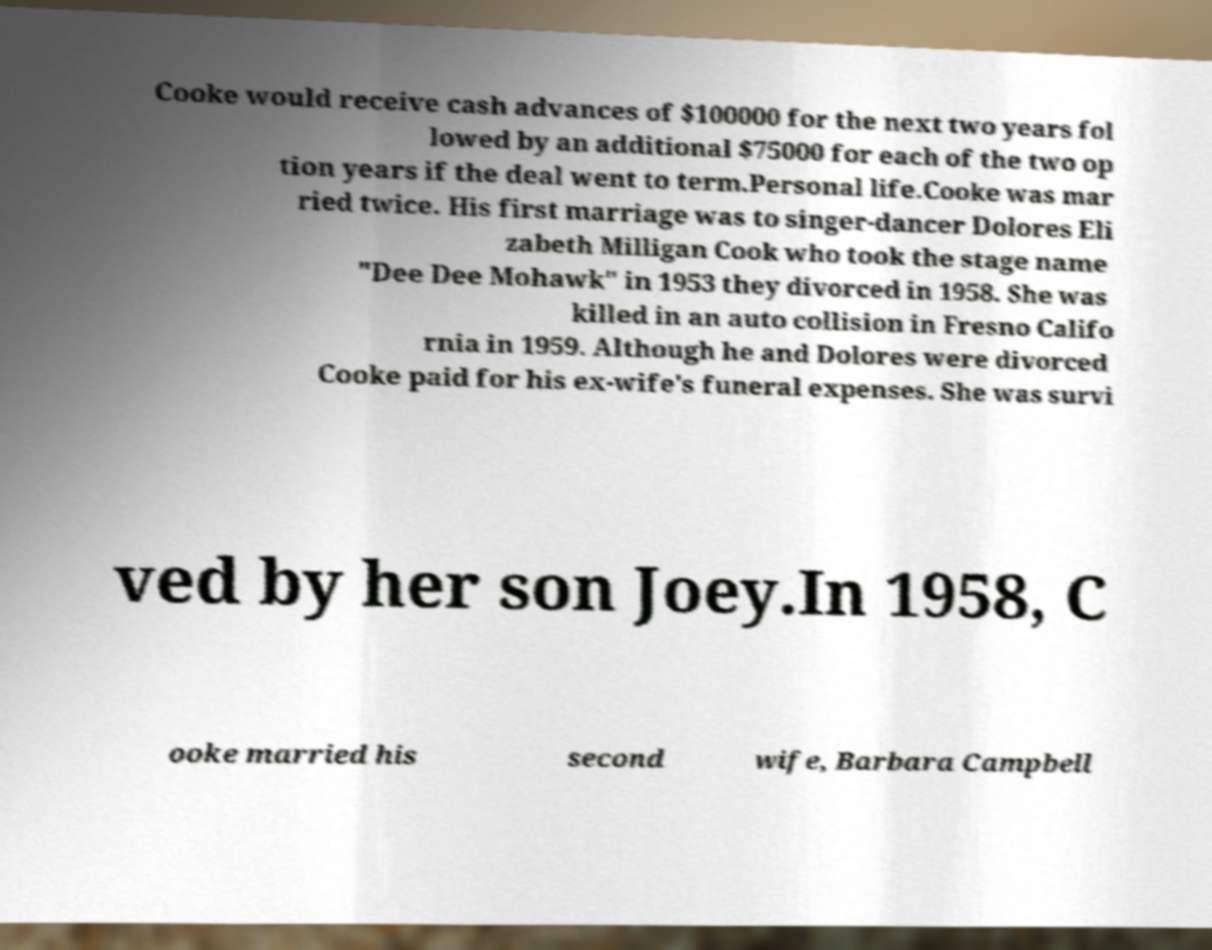I need the written content from this picture converted into text. Can you do that? Cooke would receive cash advances of $100000 for the next two years fol lowed by an additional $75000 for each of the two op tion years if the deal went to term.Personal life.Cooke was mar ried twice. His first marriage was to singer-dancer Dolores Eli zabeth Milligan Cook who took the stage name "Dee Dee Mohawk" in 1953 they divorced in 1958. She was killed in an auto collision in Fresno Califo rnia in 1959. Although he and Dolores were divorced Cooke paid for his ex-wife's funeral expenses. She was survi ved by her son Joey.In 1958, C ooke married his second wife, Barbara Campbell 